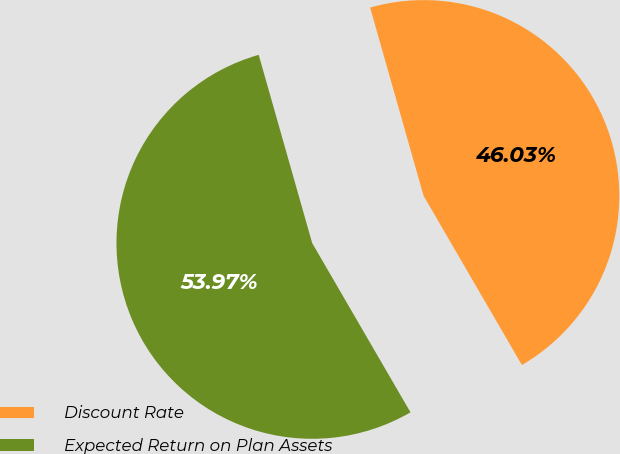Convert chart to OTSL. <chart><loc_0><loc_0><loc_500><loc_500><pie_chart><fcel>Discount Rate<fcel>Expected Return on Plan Assets<nl><fcel>46.03%<fcel>53.97%<nl></chart> 